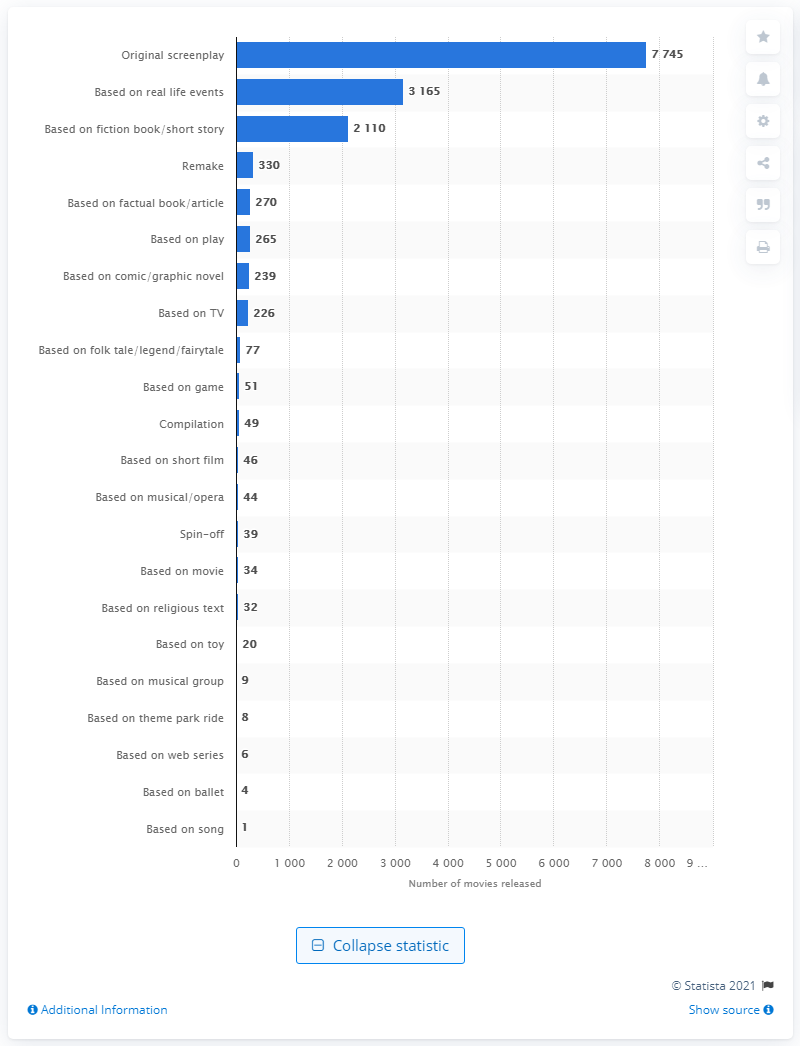Draw attention to some important aspects in this diagram. During the period between 1995 and 2020, a total of 330 remakes were produced. It is estimated that 270 movies were adapted from factual books or articles. 